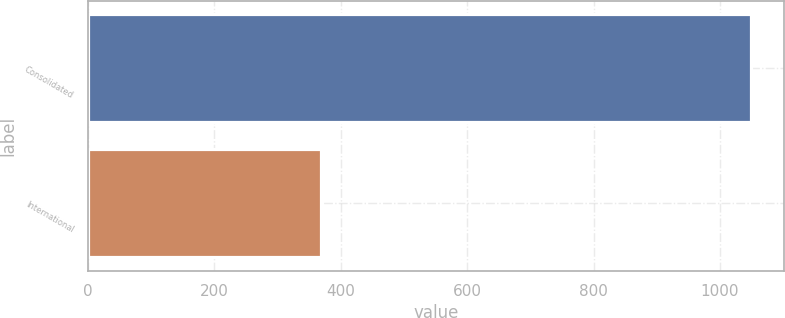Convert chart. <chart><loc_0><loc_0><loc_500><loc_500><bar_chart><fcel>Consolidated<fcel>International<nl><fcel>1048.5<fcel>369.3<nl></chart> 